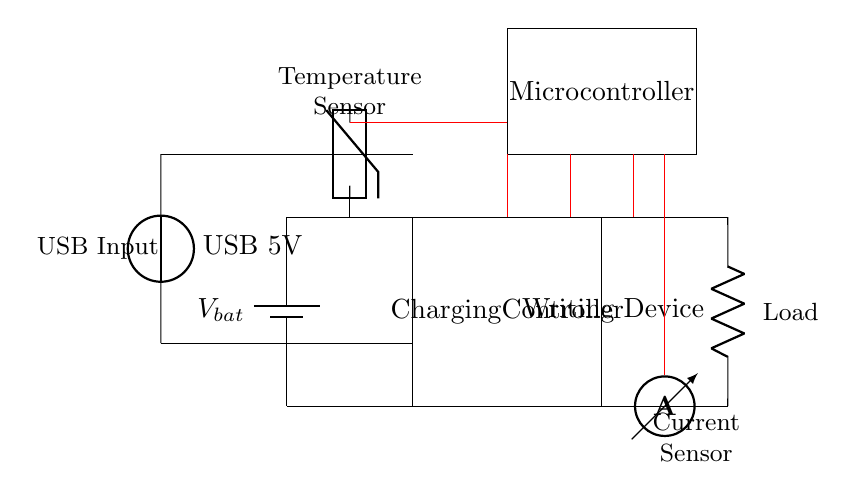What is the voltage source used for charging? The voltage source used for charging is a USB input, which provides a nominal voltage of 5 volts to the circuit.
Answer: USB 5V What component is responsible for controlling the charging process? The component responsible for controlling the charging process is labeled as the Charging Controller in the diagram. It regulates the incoming power from the USB source to properly charge the battery.
Answer: Charging Controller How many sensors are present in the circuit? There are two sensors present in the circuit: a current sensor to measure the charging current and a temperature sensor to monitor the battery temperature during charging.
Answer: 2 What does the current sensor measure in the circuit? The current sensor measures the flow of current passing through it, which is essential for monitoring the charging process and ensuring safe operation of the battery management system.
Answer: Charging current Which component is used to monitor the temperature? The component used to monitor the temperature is a thermistor, which is connected to the microcontroller for feedback on the battery's temperature during operation.
Answer: Thermistor What is the load in the circuit? The load in the circuit is identified as the Writing Device, which consumes power from the battery once it is charged and connected in the circuit.
Answer: Writing Device How does the microcontroller interact with the sensors? The microcontroller interacts with both the current sensor and the temperature sensor by receiving their respective readings and processing the data to manage the charging state and overall operation of the battery management system effectively.
Answer: By receiving data from sensors 